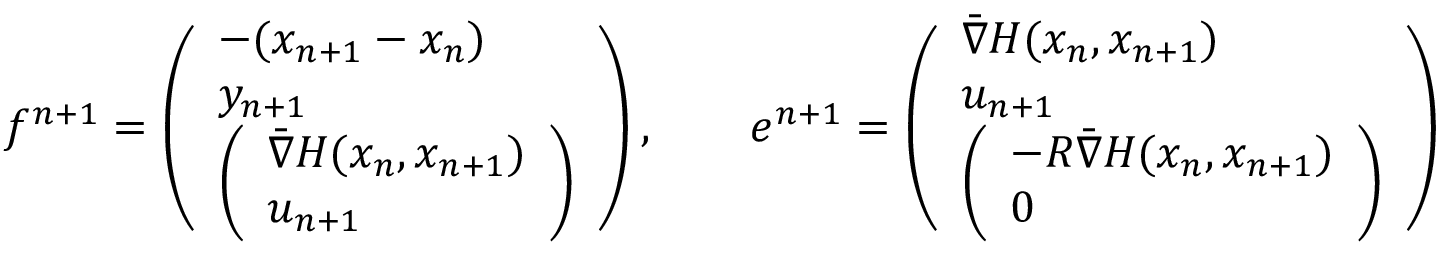<formula> <loc_0><loc_0><loc_500><loc_500>f ^ { n + 1 } = \left ( \begin{array} { l } { - ( x _ { n + 1 } - x _ { n } ) } \\ { y _ { n + 1 } } \\ { \left ( \begin{array} { l } { \bar { \nabla } H ( x _ { n } , x _ { n + 1 } ) } \\ { u _ { n + 1 } } \end{array} \right ) } \end{array} \right ) , \quad e ^ { n + 1 } = \left ( \begin{array} { l } { \bar { \nabla } H ( x _ { n } , x _ { n + 1 } ) } \\ { u _ { n + 1 } } \\ { \left ( \begin{array} { l } { - R \bar { \nabla } H ( x _ { n } , x _ { n + 1 } ) } \\ { 0 } \end{array} \right ) } \end{array} \right )</formula> 